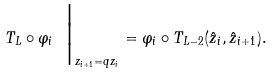<formula> <loc_0><loc_0><loc_500><loc_500>T _ { L } \circ \varphi _ { i } \ \Big | _ { z _ { i + 1 } = q z _ { i } } = \varphi _ { i } \circ T _ { L - 2 } ( \hat { z } _ { i } , \hat { z } _ { i + 1 } ) .</formula> 